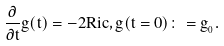<formula> <loc_0><loc_0><loc_500><loc_500>\frac { \partial } { \partial t } g ( t ) = - 2 R i c , { g ( t = 0 ) \colon = g _ { _ { 0 } } } .</formula> 